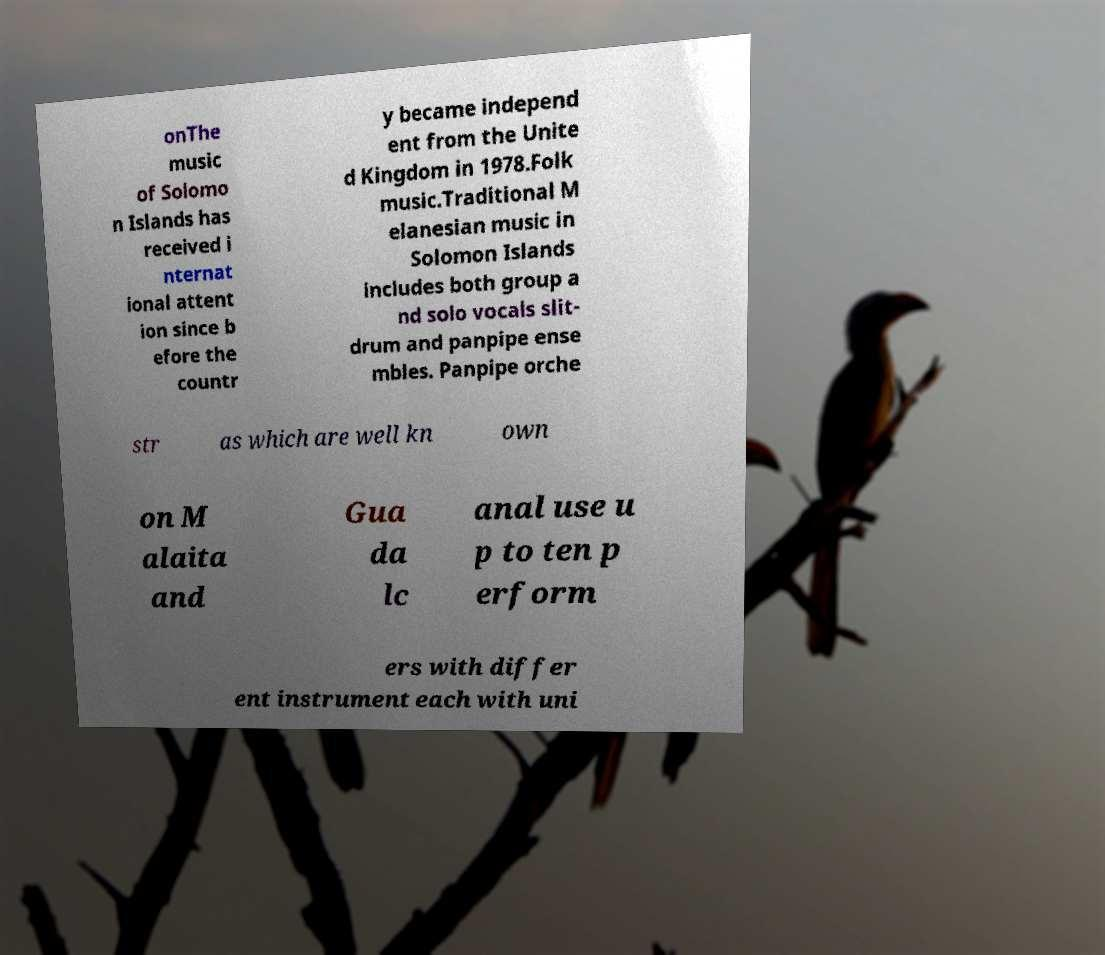For documentation purposes, I need the text within this image transcribed. Could you provide that? onThe music of Solomo n Islands has received i nternat ional attent ion since b efore the countr y became independ ent from the Unite d Kingdom in 1978.Folk music.Traditional M elanesian music in Solomon Islands includes both group a nd solo vocals slit- drum and panpipe ense mbles. Panpipe orche str as which are well kn own on M alaita and Gua da lc anal use u p to ten p erform ers with differ ent instrument each with uni 